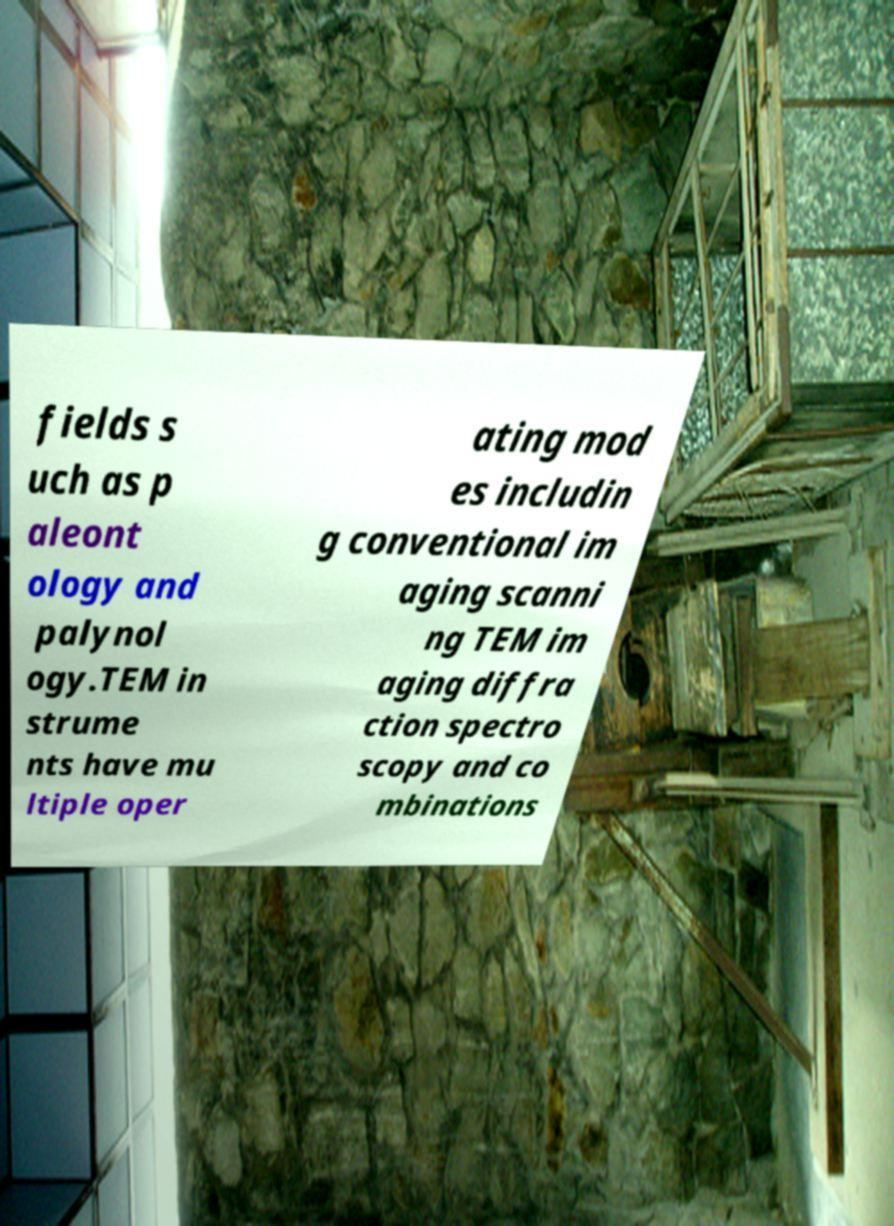Could you assist in decoding the text presented in this image and type it out clearly? fields s uch as p aleont ology and palynol ogy.TEM in strume nts have mu ltiple oper ating mod es includin g conventional im aging scanni ng TEM im aging diffra ction spectro scopy and co mbinations 